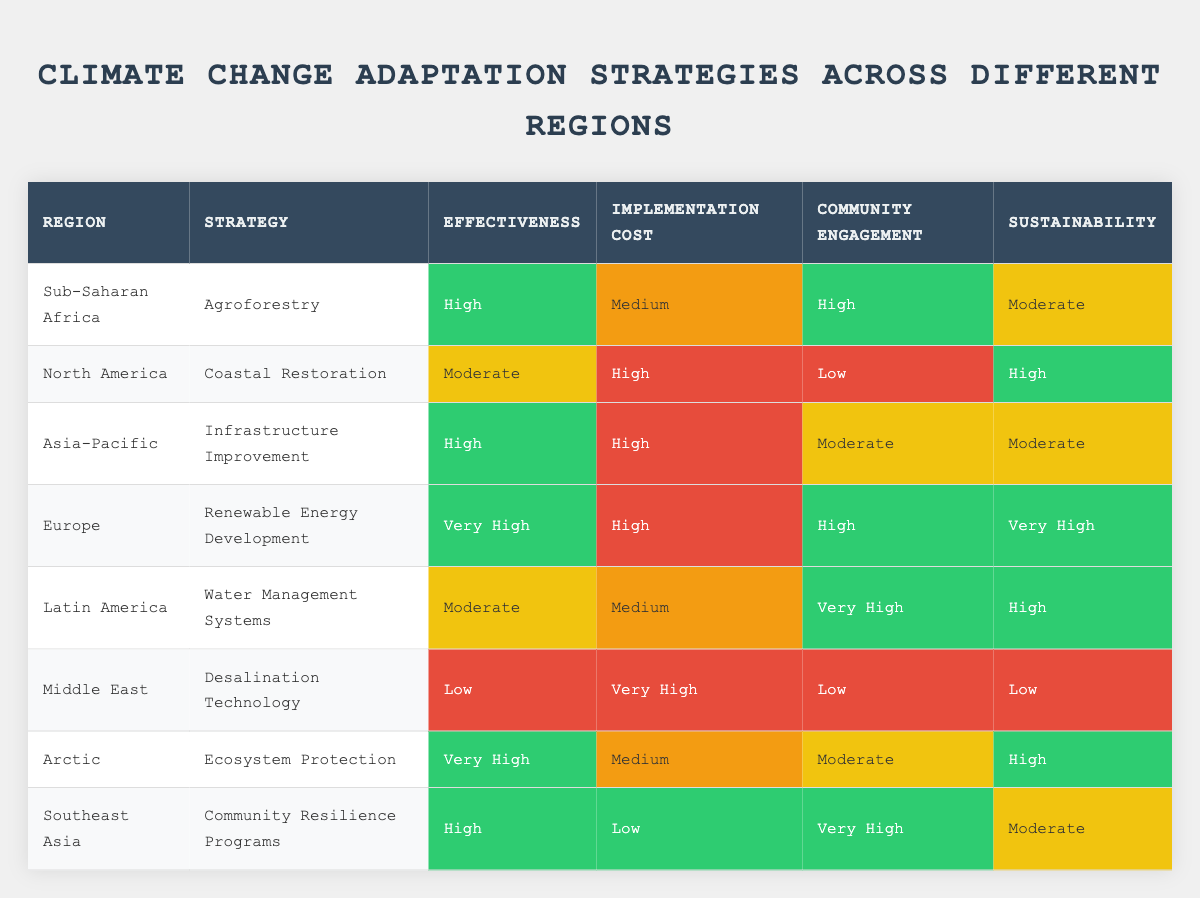What is the effectiveness of the strategy in Sub-Saharan Africa? The table lists "Agroforestry" as the strategy for Sub-Saharan Africa and its corresponding effectiveness is "High."
Answer: High Which region employs "Desalination Technology" as a strategy? According to the table, the Middle East is identified as the region that utilizes "Desalination Technology" for climate change adaptation.
Answer: Middle East Is the implementation cost of "Community Resilience Programs" low or high? The table indicates that the implementation cost of "Community Resilience Programs," which is implemented in Southeast Asia, is categorized as "Low."
Answer: Low Which region has the highest effectiveness rating among the listed strategies? When comparing the effectiveness ratings, "Renewable Energy Development" in Europe has the highest rating of "Very High," surpassing other regions and strategies.
Answer: Europe If we consider only the "High" effectiveness strategies, how many of them have high community engagement? By filtering the table for "High" effectiveness strategies, we find that "Agroforestry" (Sub-Saharan Africa), "Infrastructure Improvement" (Asia-Pacific), "Ecosystem Protection" (Arctic), and "Community Resilience Programs" (Southeast Asia) have high community engagement. Out of these, only "Agroforestry" and "Community Resilience Programs" fulfill the criteria, providing a total of 2 strategies.
Answer: 2 How many regions have a "Moderate" implementation cost? The table lists three strategies with a "Moderate" implementation cost which include "Agroforestry" (Sub-Saharan Africa), "Water Management Systems" (Latin America), and "Ecosystem Protection" (Arctic). Thus, there are three regions that fall into this category.
Answer: 3 Is there a strategy in the table with low effectiveness and high implementation cost? Looking at the table, "Desalination Technology" in the Middle East has an effectiveness rating of "Low" while the implementation cost is "Very High," confirming the existence of such a strategy.
Answer: Yes Which strategies have "Very High" sustainability ratings and are they also high in effectiveness? The table shows that "Renewable Energy Development" in Europe and "Ecosystem Protection" in the Arctic both have "Very High" sustainability ratings. Both strategies are also rated as "Very High" for effectiveness, making them consistent across these criteria.
Answer: Yes How do the effectiveness ratings of the strategies compare between North America and Southeast Asia? The effectiveness rating for "Coastal Restoration" in North America is "Moderate," while "Community Resilience Programs" in Southeast Asia is rated "High," identifying Southeast Asia as the region with a more effective strategy by comparison.
Answer: Southeast Asia has a higher effectiveness rating 